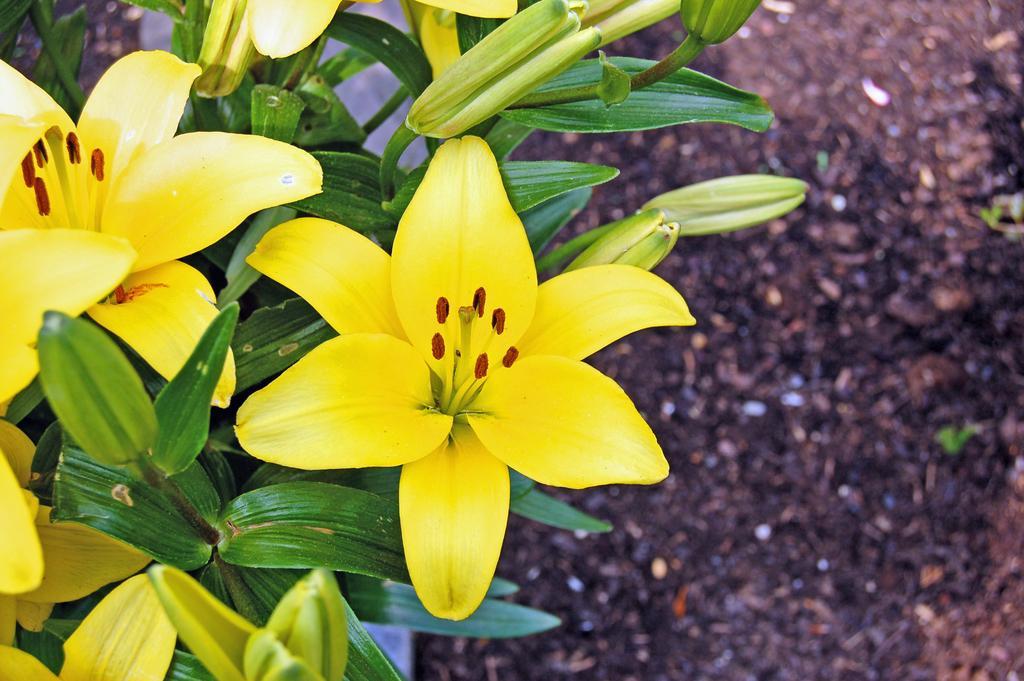How would you summarize this image in a sentence or two? In the foreground of this picture, there are few yellow colored flowers to the plants. In the background, there is the ground. 